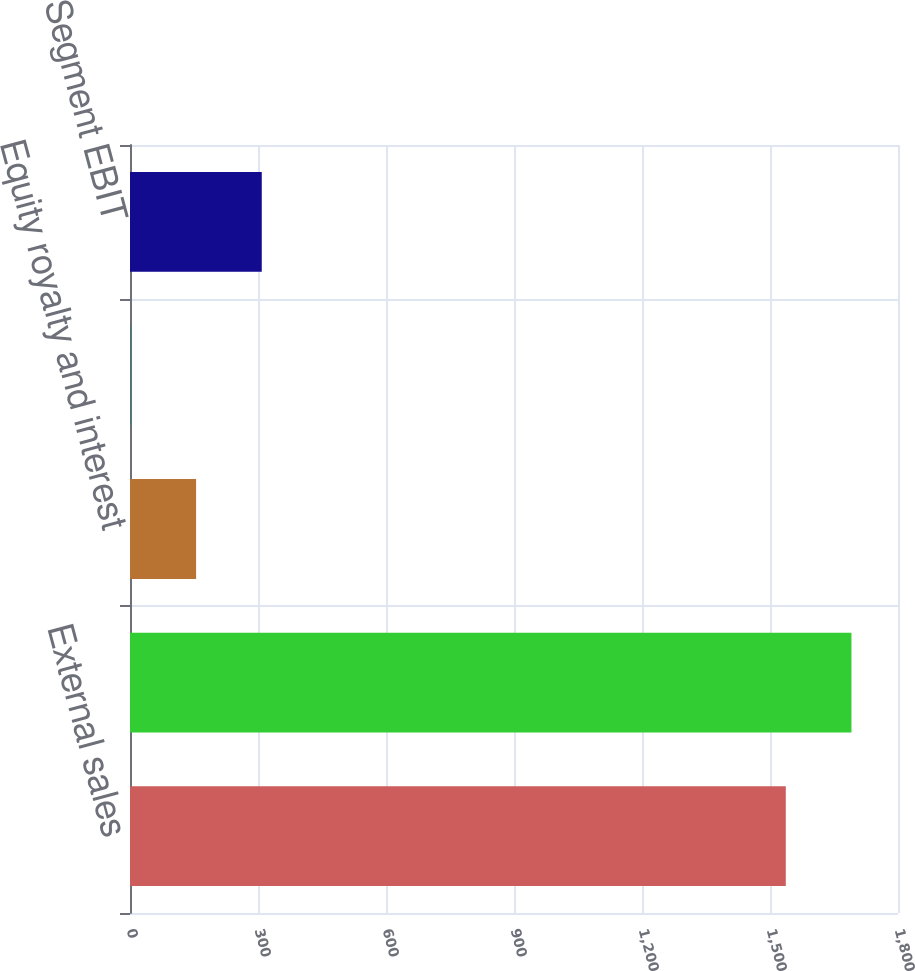<chart> <loc_0><loc_0><loc_500><loc_500><bar_chart><fcel>External sales<fcel>Total sales<fcel>Equity royalty and interest<fcel>Interest income<fcel>Segment EBIT<nl><fcel>1537<fcel>1690.9<fcel>154.9<fcel>1<fcel>308.8<nl></chart> 